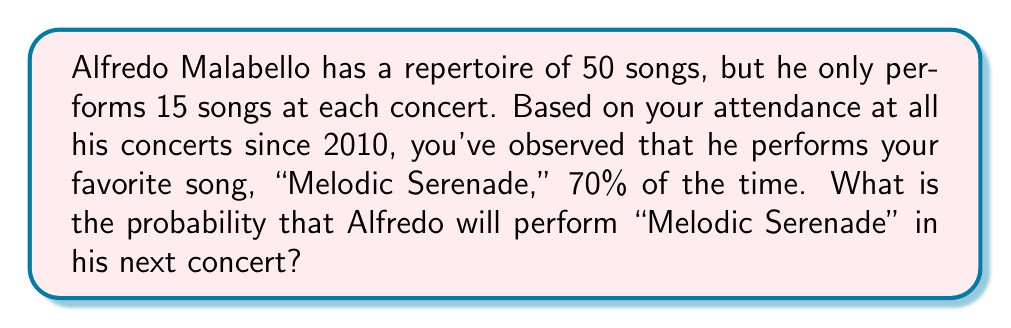Help me with this question. Let's approach this step-by-step:

1) We're dealing with a binary outcome: either Alfredo performs "Melodic Serenade" or he doesn't.

2) We're given that he performs this song 70% of the time, which means:

   $P(\text{Melodic Serenade}) = 0.70$

3) This probability is based on your observations from all concerts since 2010, which provides a large sample size and makes it a reliable estimate.

4) In probability theory, when we have a consistent probability of an event occurring over multiple trials, we can use this probability as the likelihood of the event occurring in the next trial.

5) Therefore, the probability of Alfredo performing "Melodic Serenade" in his next concert is the same as the observed frequency:

   $P(\text{Melodic Serenade in next concert}) = 0.70$

6) We can express this as a percentage:

   $0.70 \times 100\% = 70\%$

This result means that there's a 70% chance that Alfredo will perform "Melodic Serenade" in his next concert.
Answer: 70% 